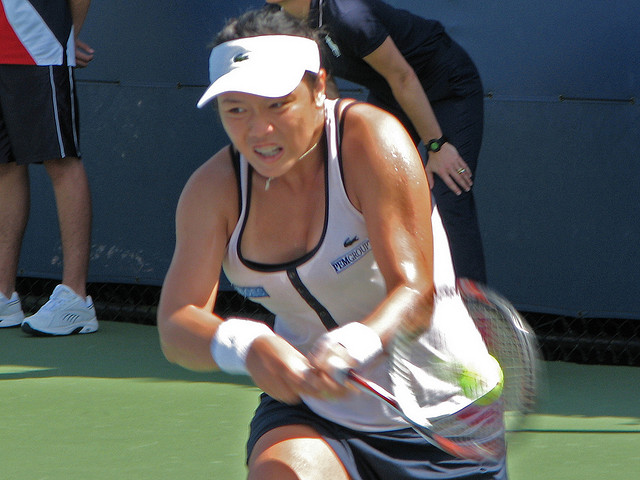Read all the text in this image. PEM GROUP 